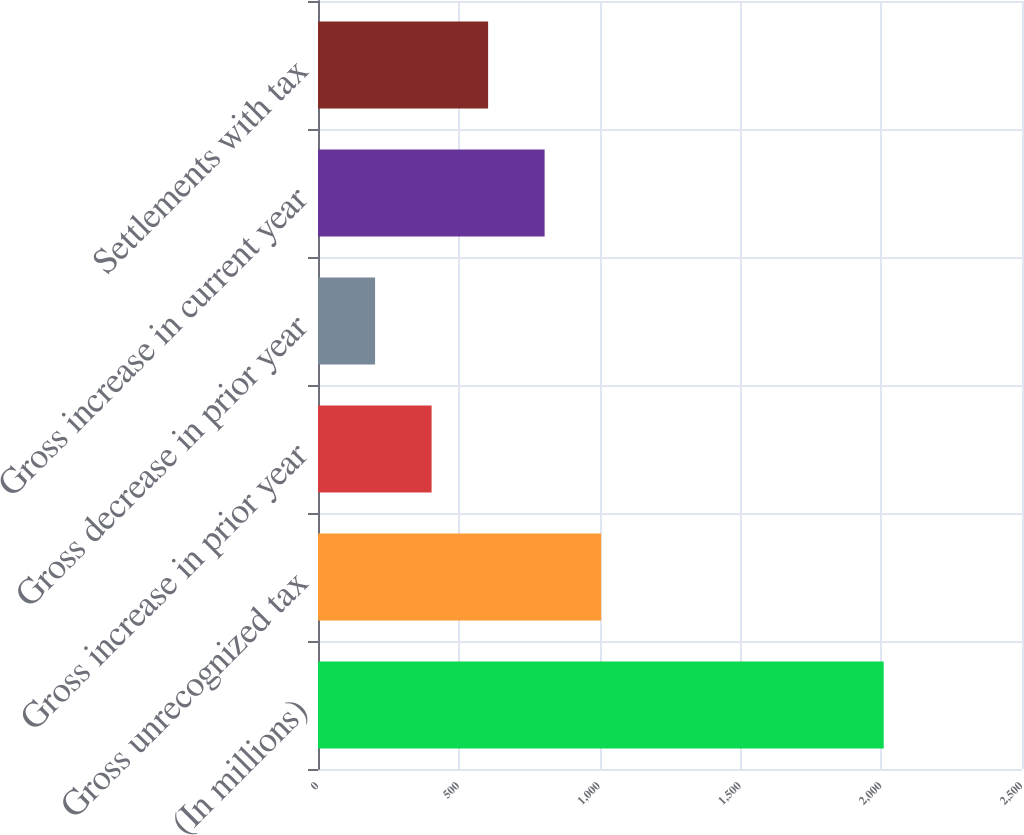Convert chart. <chart><loc_0><loc_0><loc_500><loc_500><bar_chart><fcel>(In millions)<fcel>Gross unrecognized tax<fcel>Gross increase in prior year<fcel>Gross decrease in prior year<fcel>Gross increase in current year<fcel>Settlements with tax<nl><fcel>2009<fcel>1005.5<fcel>403.4<fcel>202.7<fcel>804.8<fcel>604.1<nl></chart> 